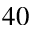<formula> <loc_0><loc_0><loc_500><loc_500>^ { 4 0 }</formula> 